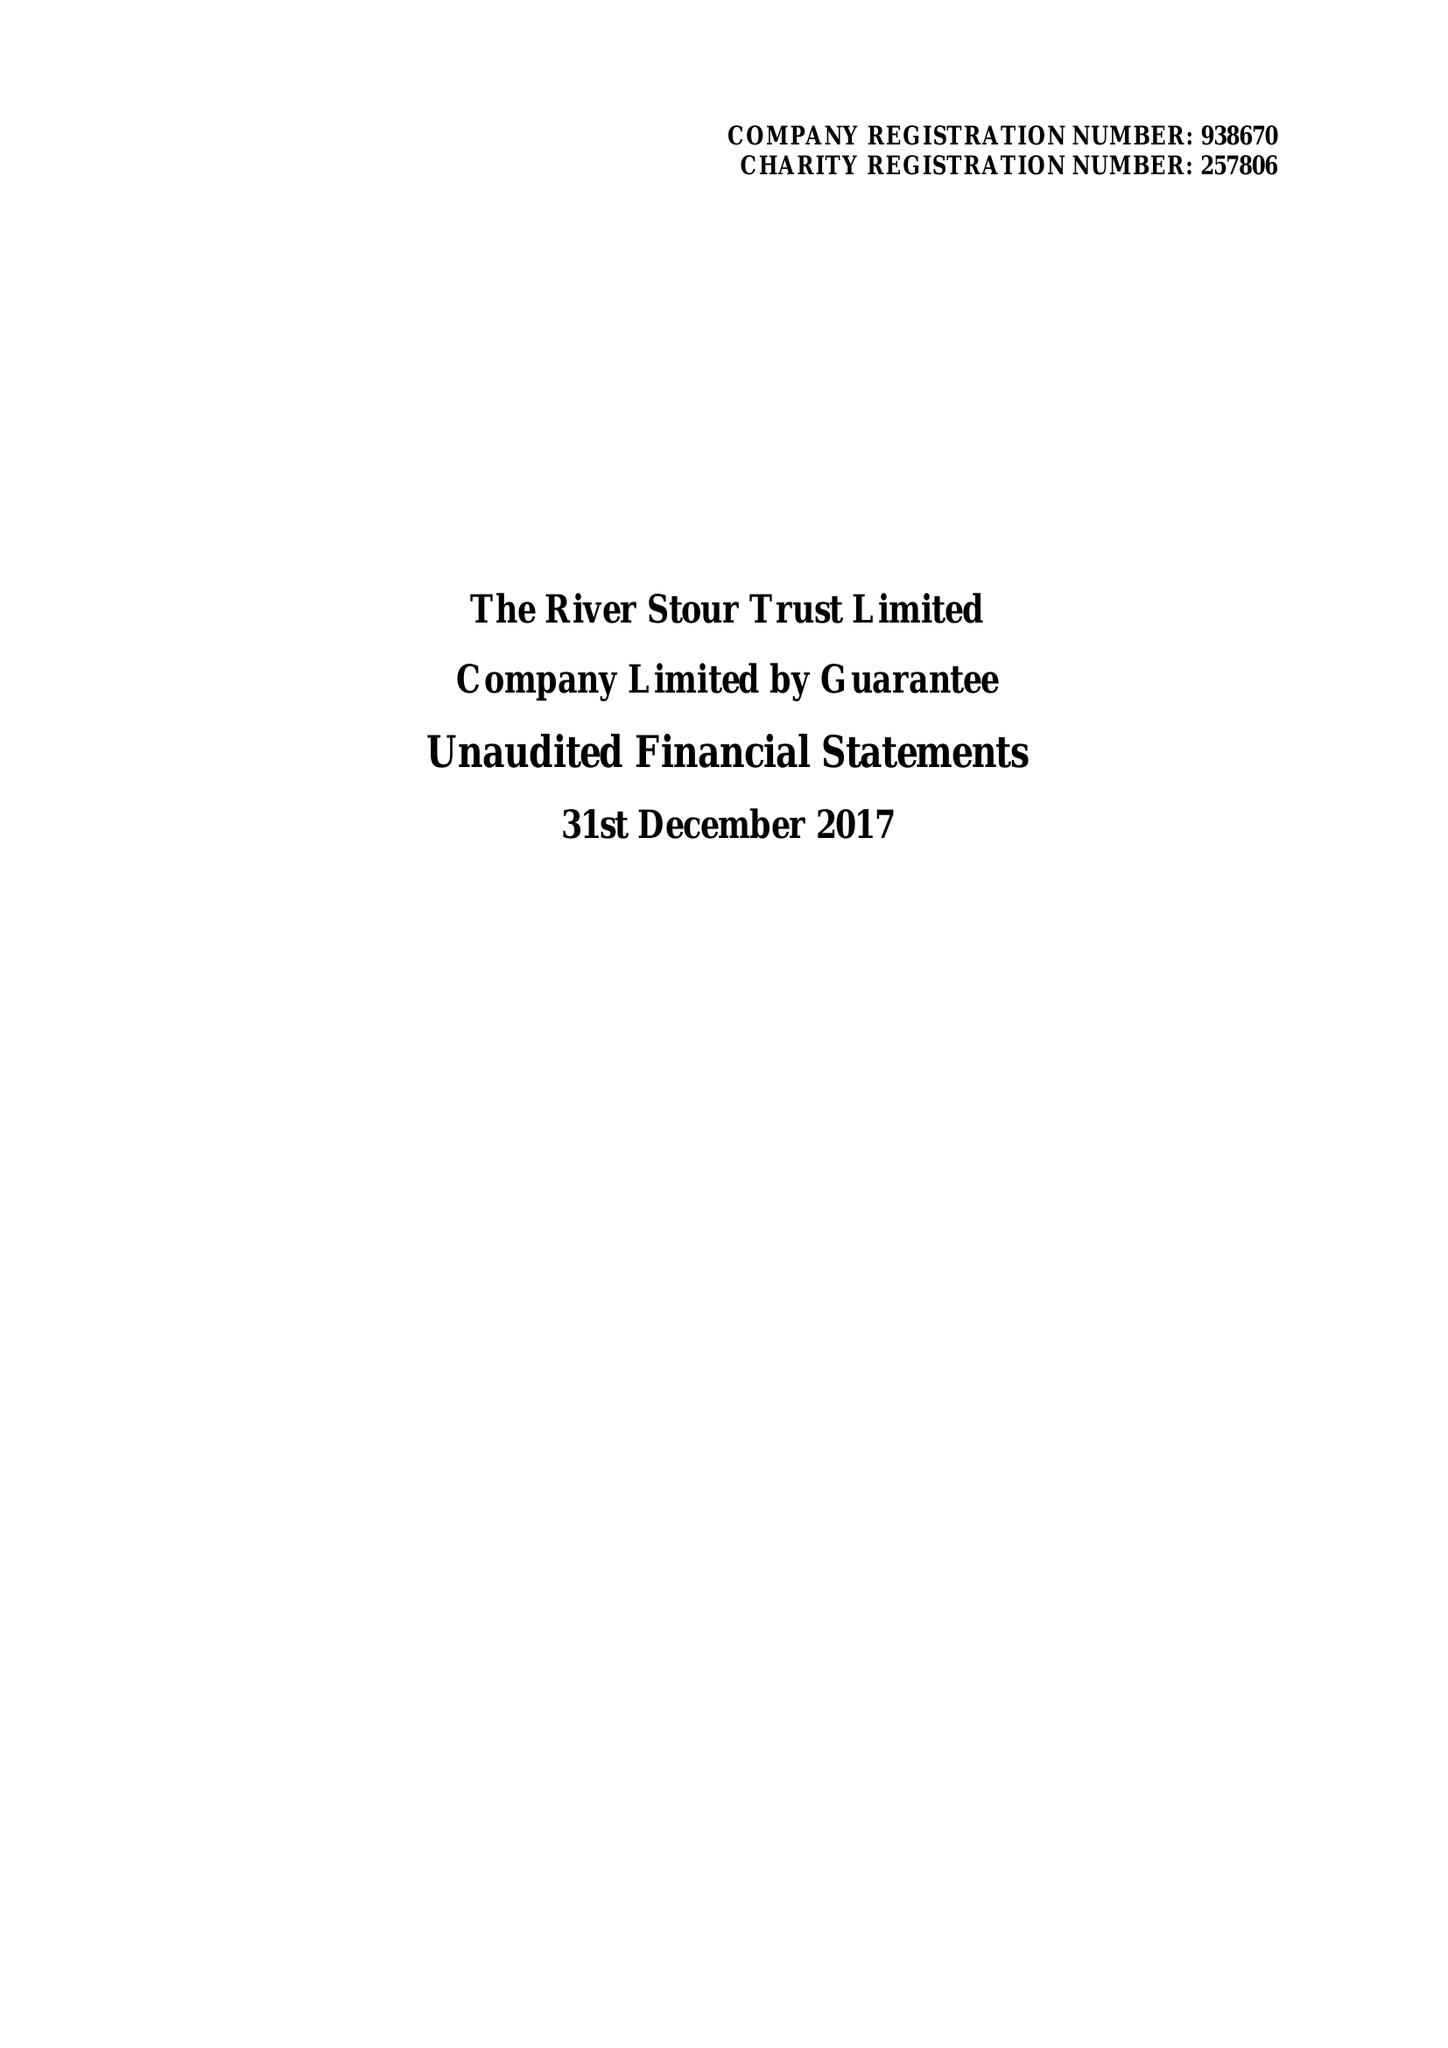What is the value for the address__post_town?
Answer the question using a single word or phrase. SUDBURY 